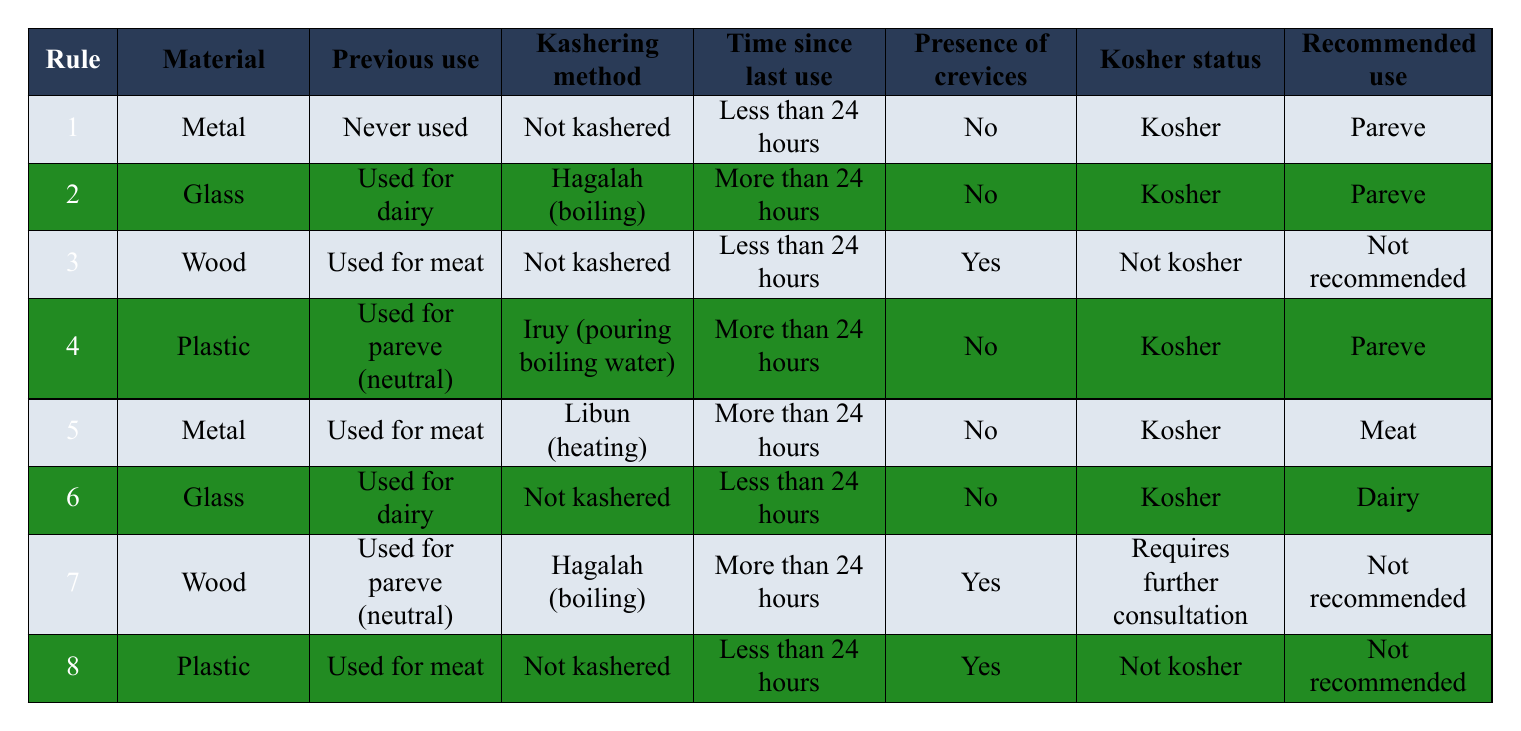What is the kosher status of a metallic utensil that has never been used? Referring to the first rule, a metallic utensil that is marked as 'Never used' is listed as 'Kosher' with a recommended use of 'Pareve.'
Answer: Kosher What is the recommended use for glass utensils used for meat? Looking through the table, there are no entries for glass used for meat. Therefore, it cannot be determined. The absence of such a case suggests there is no recommended use.
Answer: Not applicable Are woods used for pareve that have undergone Hagalah and have crevices kosher? The rule for wood used for pareve with Hagalah mentions it requires further consultation because it is listed as 'Requires further consultation' with a recommended use of 'Not recommended.'
Answer: Requires further consultation What percentage of the utensil conditions listed are considered kosher? There are 8 rules listed. Out of these, 5 rules have a 'Kosher' status (rules 1, 2, 4, 5, and 6). So, the percentage is (5/8)*100 = 62.5%.
Answer: 62.5% Is a plastic utensil that was used for meat and has crevices kosher? According to rule 8, a plastic utensil that was used for meat and has crevices is listed as 'Not kosher.'
Answer: Not kosher What is the kosher status of a glass utensil that has been used for dairy and is not kashered within 24 hours? Referring to rule 6, a glass utensil not kashered and used for dairy within 24 hours is deemed 'Kosher' and is recommended for 'Dairy.'
Answer: Kosher Which material that has been used for pareve is recommended after proper kashering? Referring to the rules, wood used for pareve with Hagalah requires further consultation, while no other rules show an alternative recommendation after kashering. Therefore, no definitive answer can be provided from the available data.
Answer: Not applicable What is the recommended use for utensils that have not been kashered and contain crevices? The only utensil listed with crevices that has not been kashered is wood used for meat, and the recommendation is 'Not recommended.'
Answer: Not recommended 